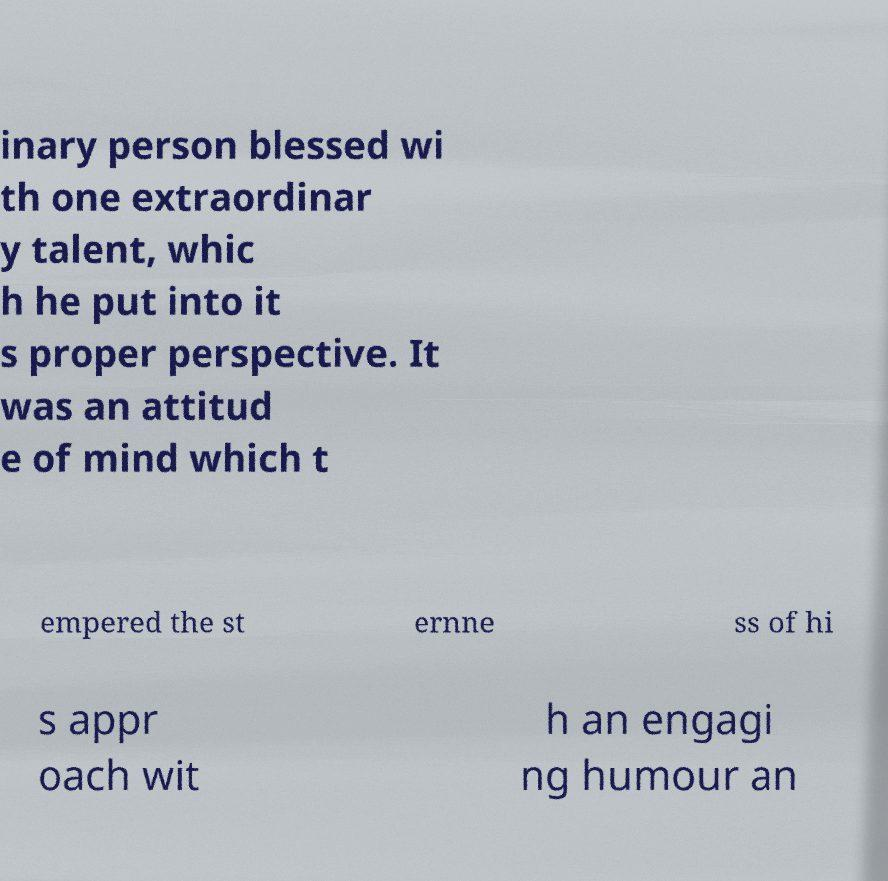Can you read and provide the text displayed in the image?This photo seems to have some interesting text. Can you extract and type it out for me? inary person blessed wi th one extraordinar y talent, whic h he put into it s proper perspective. It was an attitud e of mind which t empered the st ernne ss of hi s appr oach wit h an engagi ng humour an 